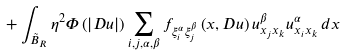<formula> <loc_0><loc_0><loc_500><loc_500>+ \int _ { \tilde { B } _ { R } } \eta ^ { 2 } \Phi \left ( \left | D u \right | \right ) \sum _ { i , j , \alpha , \beta } f _ { \xi _ { i } ^ { \alpha } \xi _ { j } ^ { \beta } } \left ( x , D u \right ) u _ { x _ { j } x _ { k } } ^ { \beta } u _ { x _ { i } x _ { k } } ^ { \alpha } \, d x</formula> 